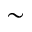<formula> <loc_0><loc_0><loc_500><loc_500>\sim</formula> 